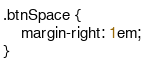Convert code to text. <code><loc_0><loc_0><loc_500><loc_500><_CSS_>.btnSpace {
    margin-right: 1em;
}</code> 